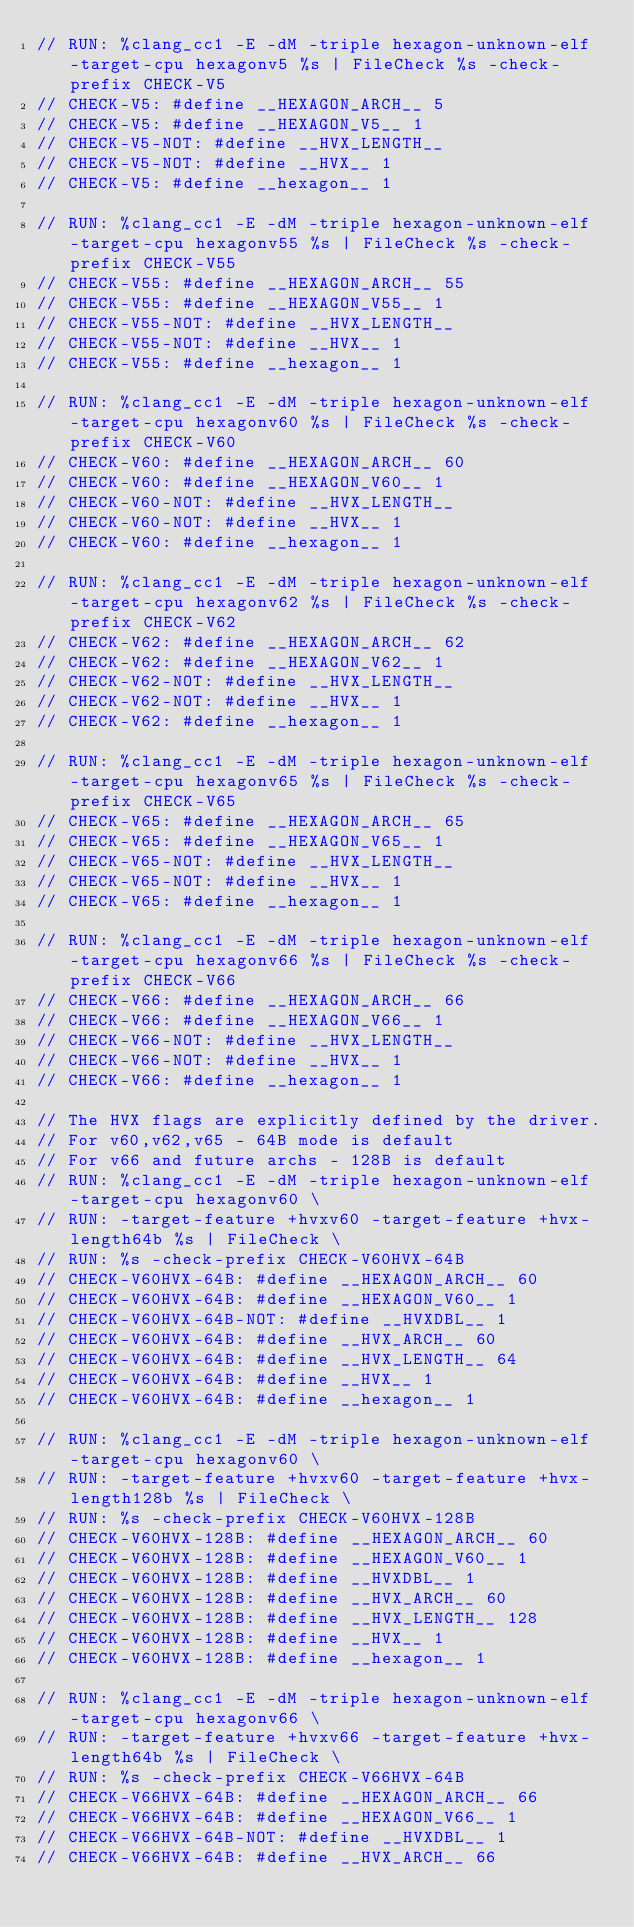<code> <loc_0><loc_0><loc_500><loc_500><_C_>// RUN: %clang_cc1 -E -dM -triple hexagon-unknown-elf -target-cpu hexagonv5 %s | FileCheck %s -check-prefix CHECK-V5
// CHECK-V5: #define __HEXAGON_ARCH__ 5
// CHECK-V5: #define __HEXAGON_V5__ 1
// CHECK-V5-NOT: #define __HVX_LENGTH__
// CHECK-V5-NOT: #define __HVX__ 1
// CHECK-V5: #define __hexagon__ 1

// RUN: %clang_cc1 -E -dM -triple hexagon-unknown-elf -target-cpu hexagonv55 %s | FileCheck %s -check-prefix CHECK-V55
// CHECK-V55: #define __HEXAGON_ARCH__ 55
// CHECK-V55: #define __HEXAGON_V55__ 1
// CHECK-V55-NOT: #define __HVX_LENGTH__
// CHECK-V55-NOT: #define __HVX__ 1
// CHECK-V55: #define __hexagon__ 1

// RUN: %clang_cc1 -E -dM -triple hexagon-unknown-elf -target-cpu hexagonv60 %s | FileCheck %s -check-prefix CHECK-V60
// CHECK-V60: #define __HEXAGON_ARCH__ 60
// CHECK-V60: #define __HEXAGON_V60__ 1
// CHECK-V60-NOT: #define __HVX_LENGTH__
// CHECK-V60-NOT: #define __HVX__ 1
// CHECK-V60: #define __hexagon__ 1

// RUN: %clang_cc1 -E -dM -triple hexagon-unknown-elf -target-cpu hexagonv62 %s | FileCheck %s -check-prefix CHECK-V62
// CHECK-V62: #define __HEXAGON_ARCH__ 62
// CHECK-V62: #define __HEXAGON_V62__ 1
// CHECK-V62-NOT: #define __HVX_LENGTH__
// CHECK-V62-NOT: #define __HVX__ 1
// CHECK-V62: #define __hexagon__ 1

// RUN: %clang_cc1 -E -dM -triple hexagon-unknown-elf -target-cpu hexagonv65 %s | FileCheck %s -check-prefix CHECK-V65
// CHECK-V65: #define __HEXAGON_ARCH__ 65
// CHECK-V65: #define __HEXAGON_V65__ 1
// CHECK-V65-NOT: #define __HVX_LENGTH__
// CHECK-V65-NOT: #define __HVX__ 1
// CHECK-V65: #define __hexagon__ 1

// RUN: %clang_cc1 -E -dM -triple hexagon-unknown-elf -target-cpu hexagonv66 %s | FileCheck %s -check-prefix CHECK-V66
// CHECK-V66: #define __HEXAGON_ARCH__ 66
// CHECK-V66: #define __HEXAGON_V66__ 1
// CHECK-V66-NOT: #define __HVX_LENGTH__
// CHECK-V66-NOT: #define __HVX__ 1
// CHECK-V66: #define __hexagon__ 1

// The HVX flags are explicitly defined by the driver.
// For v60,v62,v65 - 64B mode is default
// For v66 and future archs - 128B is default
// RUN: %clang_cc1 -E -dM -triple hexagon-unknown-elf -target-cpu hexagonv60 \
// RUN: -target-feature +hvxv60 -target-feature +hvx-length64b %s | FileCheck \
// RUN: %s -check-prefix CHECK-V60HVX-64B
// CHECK-V60HVX-64B: #define __HEXAGON_ARCH__ 60
// CHECK-V60HVX-64B: #define __HEXAGON_V60__ 1
// CHECK-V60HVX-64B-NOT: #define __HVXDBL__ 1
// CHECK-V60HVX-64B: #define __HVX_ARCH__ 60
// CHECK-V60HVX-64B: #define __HVX_LENGTH__ 64
// CHECK-V60HVX-64B: #define __HVX__ 1
// CHECK-V60HVX-64B: #define __hexagon__ 1

// RUN: %clang_cc1 -E -dM -triple hexagon-unknown-elf -target-cpu hexagonv60 \
// RUN: -target-feature +hvxv60 -target-feature +hvx-length128b %s | FileCheck \
// RUN: %s -check-prefix CHECK-V60HVX-128B
// CHECK-V60HVX-128B: #define __HEXAGON_ARCH__ 60
// CHECK-V60HVX-128B: #define __HEXAGON_V60__ 1
// CHECK-V60HVX-128B: #define __HVXDBL__ 1
// CHECK-V60HVX-128B: #define __HVX_ARCH__ 60
// CHECK-V60HVX-128B: #define __HVX_LENGTH__ 128
// CHECK-V60HVX-128B: #define __HVX__ 1
// CHECK-V60HVX-128B: #define __hexagon__ 1

// RUN: %clang_cc1 -E -dM -triple hexagon-unknown-elf -target-cpu hexagonv66 \
// RUN: -target-feature +hvxv66 -target-feature +hvx-length64b %s | FileCheck \
// RUN: %s -check-prefix CHECK-V66HVX-64B
// CHECK-V66HVX-64B: #define __HEXAGON_ARCH__ 66
// CHECK-V66HVX-64B: #define __HEXAGON_V66__ 1
// CHECK-V66HVX-64B-NOT: #define __HVXDBL__ 1
// CHECK-V66HVX-64B: #define __HVX_ARCH__ 66</code> 